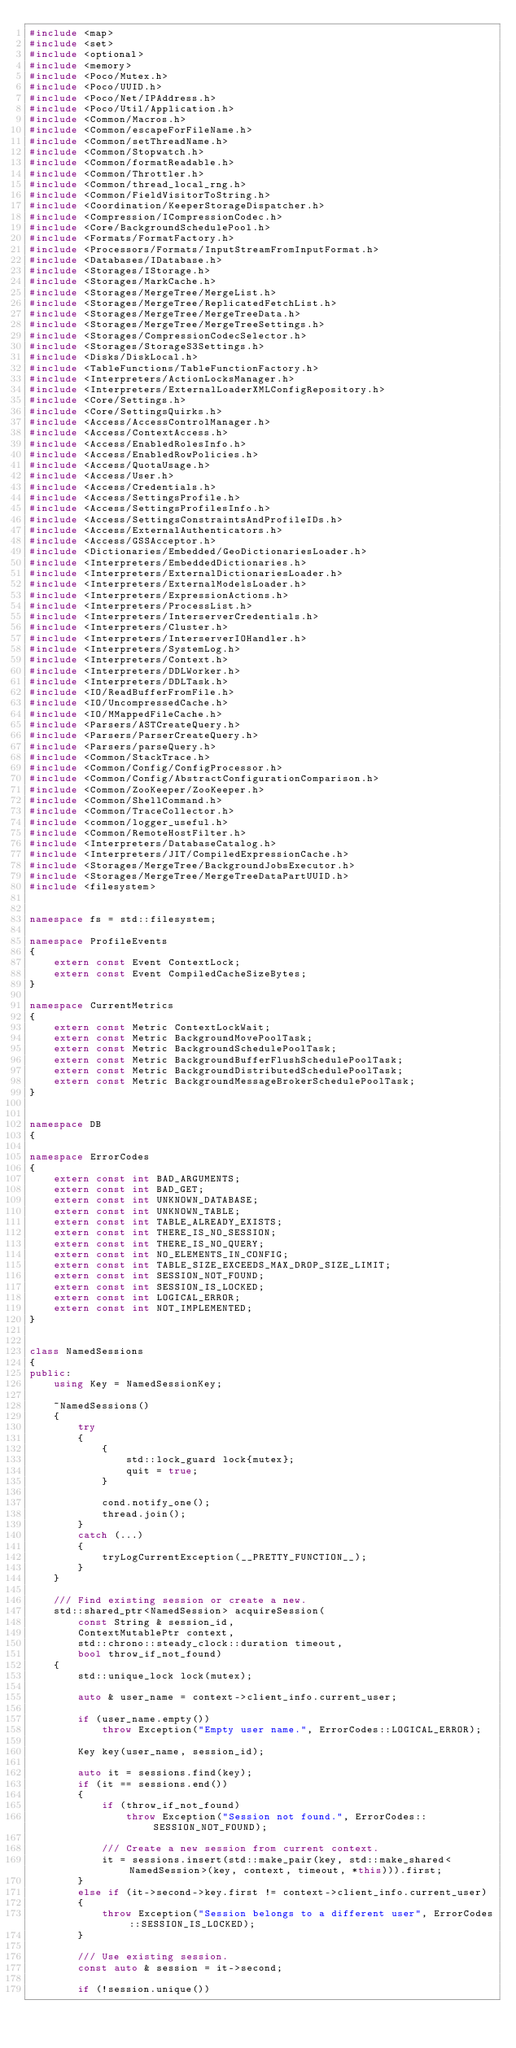Convert code to text. <code><loc_0><loc_0><loc_500><loc_500><_C++_>#include <map>
#include <set>
#include <optional>
#include <memory>
#include <Poco/Mutex.h>
#include <Poco/UUID.h>
#include <Poco/Net/IPAddress.h>
#include <Poco/Util/Application.h>
#include <Common/Macros.h>
#include <Common/escapeForFileName.h>
#include <Common/setThreadName.h>
#include <Common/Stopwatch.h>
#include <Common/formatReadable.h>
#include <Common/Throttler.h>
#include <Common/thread_local_rng.h>
#include <Common/FieldVisitorToString.h>
#include <Coordination/KeeperStorageDispatcher.h>
#include <Compression/ICompressionCodec.h>
#include <Core/BackgroundSchedulePool.h>
#include <Formats/FormatFactory.h>
#include <Processors/Formats/InputStreamFromInputFormat.h>
#include <Databases/IDatabase.h>
#include <Storages/IStorage.h>
#include <Storages/MarkCache.h>
#include <Storages/MergeTree/MergeList.h>
#include <Storages/MergeTree/ReplicatedFetchList.h>
#include <Storages/MergeTree/MergeTreeData.h>
#include <Storages/MergeTree/MergeTreeSettings.h>
#include <Storages/CompressionCodecSelector.h>
#include <Storages/StorageS3Settings.h>
#include <Disks/DiskLocal.h>
#include <TableFunctions/TableFunctionFactory.h>
#include <Interpreters/ActionLocksManager.h>
#include <Interpreters/ExternalLoaderXMLConfigRepository.h>
#include <Core/Settings.h>
#include <Core/SettingsQuirks.h>
#include <Access/AccessControlManager.h>
#include <Access/ContextAccess.h>
#include <Access/EnabledRolesInfo.h>
#include <Access/EnabledRowPolicies.h>
#include <Access/QuotaUsage.h>
#include <Access/User.h>
#include <Access/Credentials.h>
#include <Access/SettingsProfile.h>
#include <Access/SettingsProfilesInfo.h>
#include <Access/SettingsConstraintsAndProfileIDs.h>
#include <Access/ExternalAuthenticators.h>
#include <Access/GSSAcceptor.h>
#include <Dictionaries/Embedded/GeoDictionariesLoader.h>
#include <Interpreters/EmbeddedDictionaries.h>
#include <Interpreters/ExternalDictionariesLoader.h>
#include <Interpreters/ExternalModelsLoader.h>
#include <Interpreters/ExpressionActions.h>
#include <Interpreters/ProcessList.h>
#include <Interpreters/InterserverCredentials.h>
#include <Interpreters/Cluster.h>
#include <Interpreters/InterserverIOHandler.h>
#include <Interpreters/SystemLog.h>
#include <Interpreters/Context.h>
#include <Interpreters/DDLWorker.h>
#include <Interpreters/DDLTask.h>
#include <IO/ReadBufferFromFile.h>
#include <IO/UncompressedCache.h>
#include <IO/MMappedFileCache.h>
#include <Parsers/ASTCreateQuery.h>
#include <Parsers/ParserCreateQuery.h>
#include <Parsers/parseQuery.h>
#include <Common/StackTrace.h>
#include <Common/Config/ConfigProcessor.h>
#include <Common/Config/AbstractConfigurationComparison.h>
#include <Common/ZooKeeper/ZooKeeper.h>
#include <Common/ShellCommand.h>
#include <Common/TraceCollector.h>
#include <common/logger_useful.h>
#include <Common/RemoteHostFilter.h>
#include <Interpreters/DatabaseCatalog.h>
#include <Interpreters/JIT/CompiledExpressionCache.h>
#include <Storages/MergeTree/BackgroundJobsExecutor.h>
#include <Storages/MergeTree/MergeTreeDataPartUUID.h>
#include <filesystem>


namespace fs = std::filesystem;

namespace ProfileEvents
{
    extern const Event ContextLock;
    extern const Event CompiledCacheSizeBytes;
}

namespace CurrentMetrics
{
    extern const Metric ContextLockWait;
    extern const Metric BackgroundMovePoolTask;
    extern const Metric BackgroundSchedulePoolTask;
    extern const Metric BackgroundBufferFlushSchedulePoolTask;
    extern const Metric BackgroundDistributedSchedulePoolTask;
    extern const Metric BackgroundMessageBrokerSchedulePoolTask;
}


namespace DB
{

namespace ErrorCodes
{
    extern const int BAD_ARGUMENTS;
    extern const int BAD_GET;
    extern const int UNKNOWN_DATABASE;
    extern const int UNKNOWN_TABLE;
    extern const int TABLE_ALREADY_EXISTS;
    extern const int THERE_IS_NO_SESSION;
    extern const int THERE_IS_NO_QUERY;
    extern const int NO_ELEMENTS_IN_CONFIG;
    extern const int TABLE_SIZE_EXCEEDS_MAX_DROP_SIZE_LIMIT;
    extern const int SESSION_NOT_FOUND;
    extern const int SESSION_IS_LOCKED;
    extern const int LOGICAL_ERROR;
    extern const int NOT_IMPLEMENTED;
}


class NamedSessions
{
public:
    using Key = NamedSessionKey;

    ~NamedSessions()
    {
        try
        {
            {
                std::lock_guard lock{mutex};
                quit = true;
            }

            cond.notify_one();
            thread.join();
        }
        catch (...)
        {
            tryLogCurrentException(__PRETTY_FUNCTION__);
        }
    }

    /// Find existing session or create a new.
    std::shared_ptr<NamedSession> acquireSession(
        const String & session_id,
        ContextMutablePtr context,
        std::chrono::steady_clock::duration timeout,
        bool throw_if_not_found)
    {
        std::unique_lock lock(mutex);

        auto & user_name = context->client_info.current_user;

        if (user_name.empty())
            throw Exception("Empty user name.", ErrorCodes::LOGICAL_ERROR);

        Key key(user_name, session_id);

        auto it = sessions.find(key);
        if (it == sessions.end())
        {
            if (throw_if_not_found)
                throw Exception("Session not found.", ErrorCodes::SESSION_NOT_FOUND);

            /// Create a new session from current context.
            it = sessions.insert(std::make_pair(key, std::make_shared<NamedSession>(key, context, timeout, *this))).first;
        }
        else if (it->second->key.first != context->client_info.current_user)
        {
            throw Exception("Session belongs to a different user", ErrorCodes::SESSION_IS_LOCKED);
        }

        /// Use existing session.
        const auto & session = it->second;

        if (!session.unique())</code> 